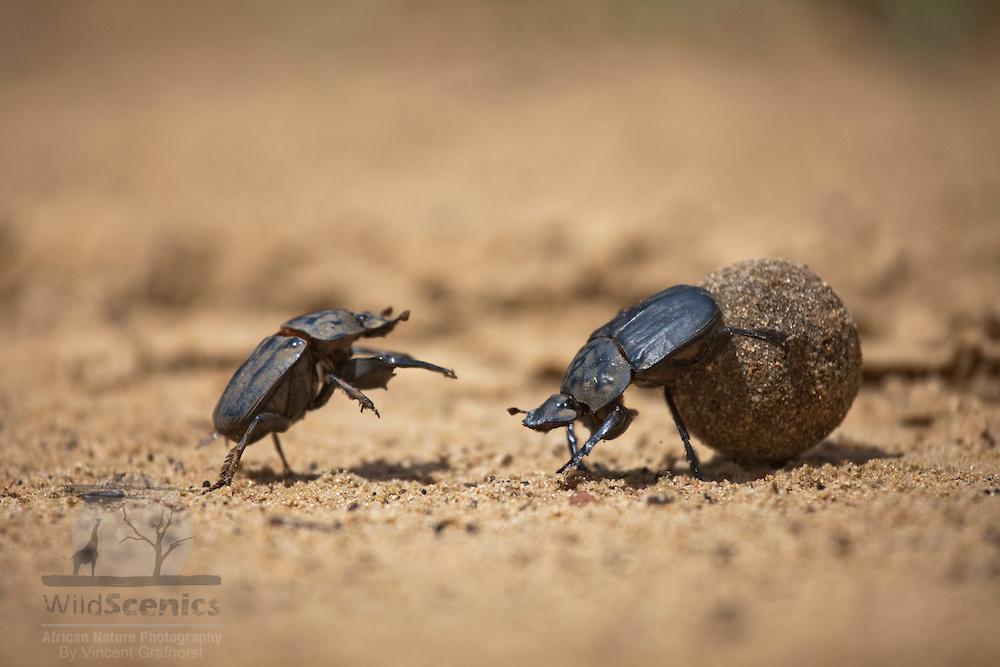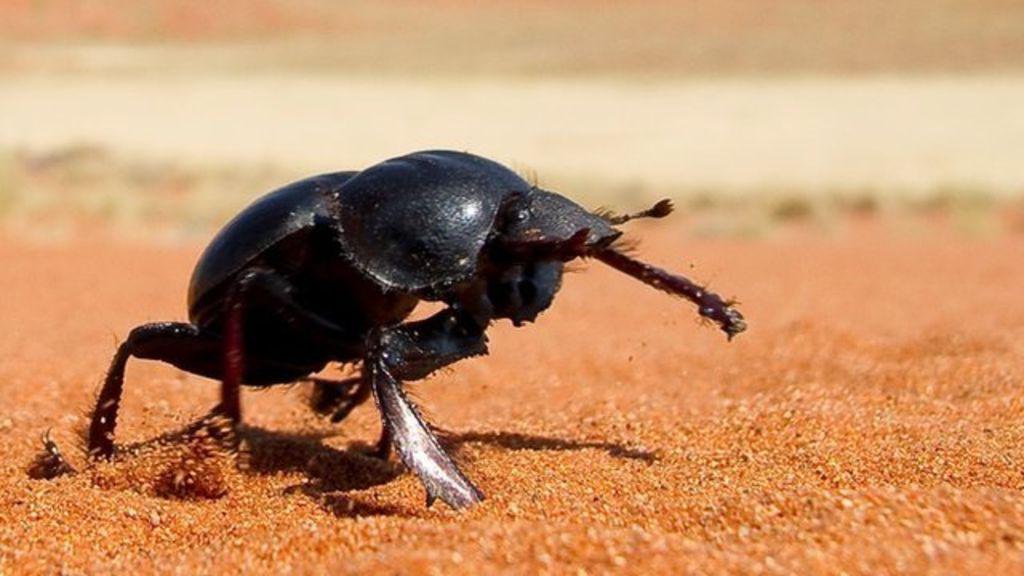The first image is the image on the left, the second image is the image on the right. Given the left and right images, does the statement "In one image, one beetle is on the ground next to a beetle on a dung ball." hold true? Answer yes or no. Yes. The first image is the image on the left, the second image is the image on the right. For the images displayed, is the sentence "The image on the left contains two insects." factually correct? Answer yes or no. Yes. The first image is the image on the left, the second image is the image on the right. Analyze the images presented: Is the assertion "there are two insects in the image on the left." valid? Answer yes or no. Yes. 